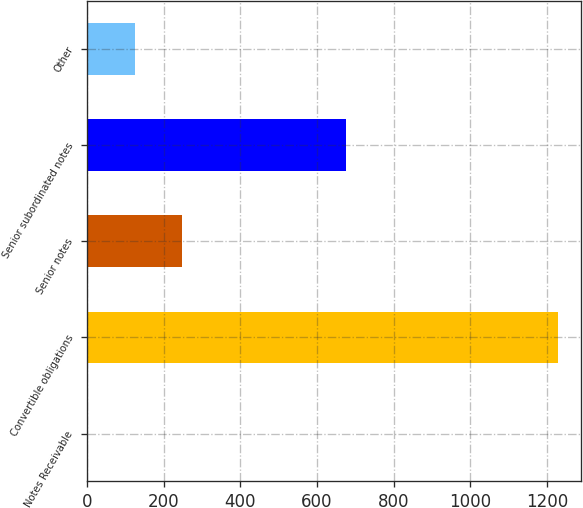<chart> <loc_0><loc_0><loc_500><loc_500><bar_chart><fcel>Notes Receivable<fcel>Convertible obligations<fcel>Senior notes<fcel>Senior subordinated notes<fcel>Other<nl><fcel>2.7<fcel>1227.7<fcel>247.7<fcel>675.9<fcel>125.2<nl></chart> 